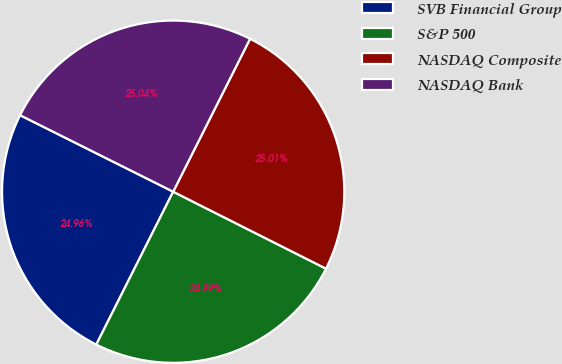Convert chart to OTSL. <chart><loc_0><loc_0><loc_500><loc_500><pie_chart><fcel>SVB Financial Group<fcel>S&P 500<fcel>NASDAQ Composite<fcel>NASDAQ Bank<nl><fcel>24.96%<fcel>24.99%<fcel>25.01%<fcel>25.04%<nl></chart> 